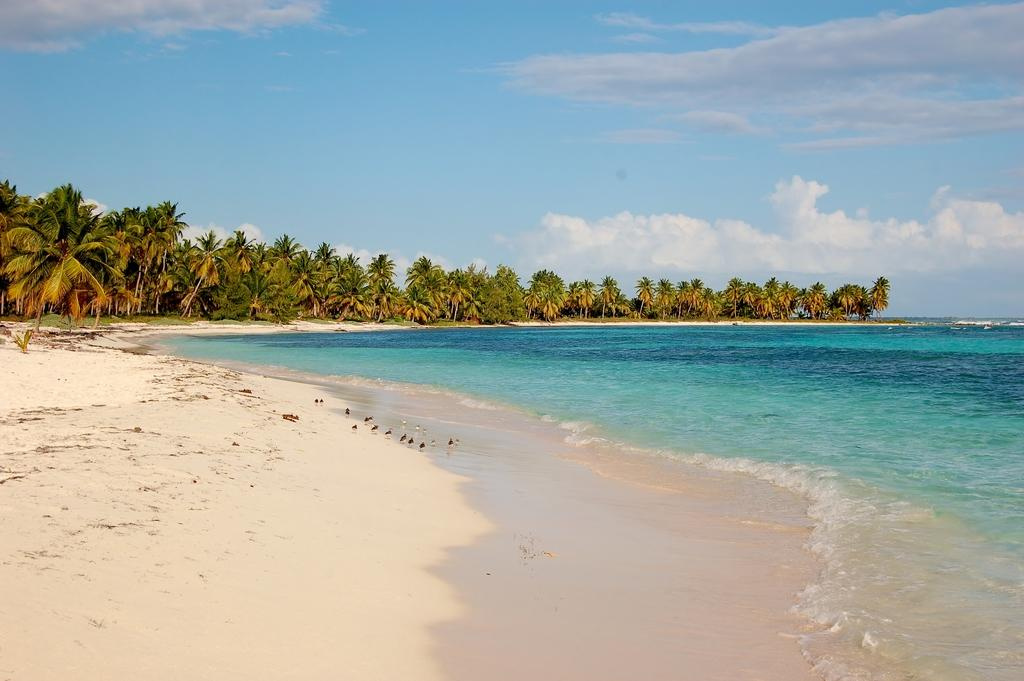What type of vegetation can be seen in the middle of the image? There are trees in the middle of the image. What natural feature is located on the right side of the image? There is a sea on the right side of the image. What is visible at the top of the image? The sky is visible at the top of the image. How would you describe the sky's appearance in the image? The sky appears to be cloudy. How many boats are visible in the image? There are no boats present in the image. What color is the nose of the person in the image? There is no person or nose present in the image. 